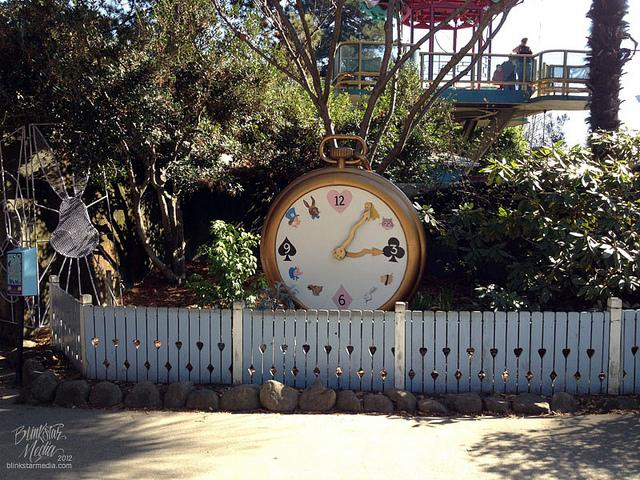This area is based on which author's works? lewis carroll 